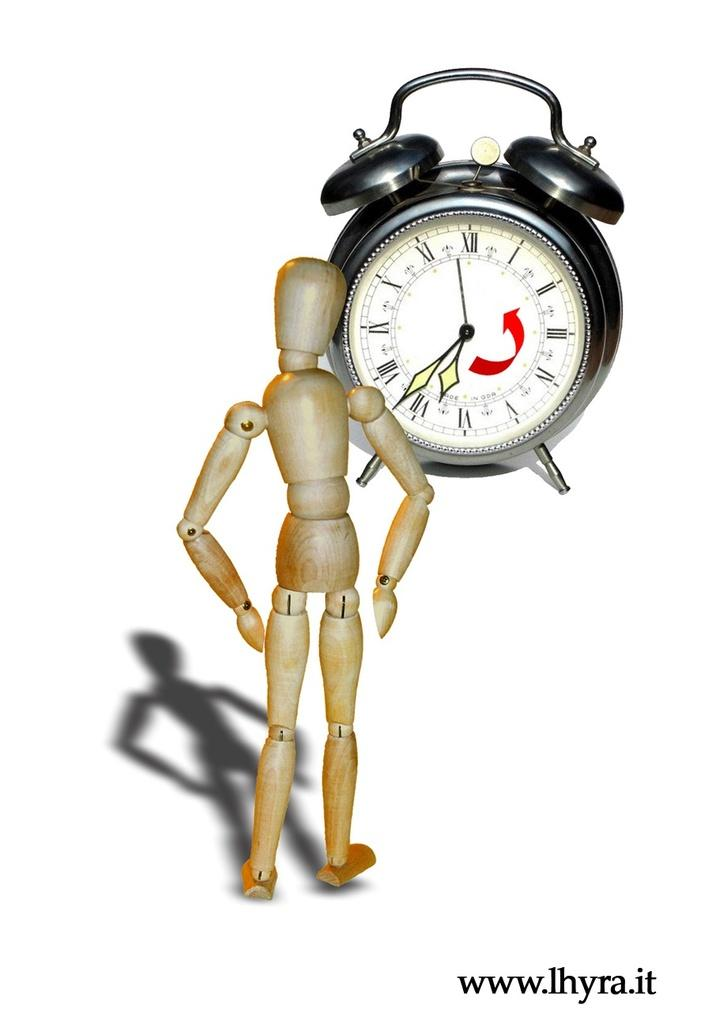<image>
Give a short and clear explanation of the subsequent image. a wooden man is looking at at clock that says 7:37 